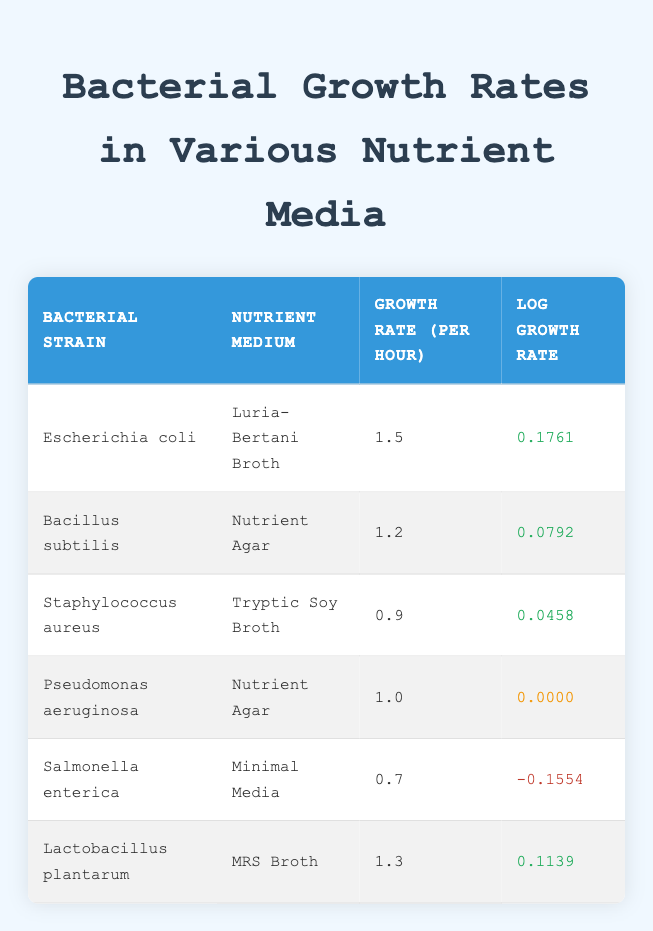What is the growth rate per hour of Escherichia coli in Luria-Bertani Broth? The table directly shows that the growth rate per hour for Escherichia coli in Luria-Bertani Broth is 1.5.
Answer: 1.5 Which bacterial strain has the highest growth rate per hour? By comparing the growth rates of all strains, Escherichia coli has the highest growth rate of 1.5 per hour.
Answer: Escherichia coli What is the log growth rate of Salmonella enterica? The table indicates that the log growth rate for Salmonella enterica is -0.1554.
Answer: -0.1554 Is the growth rate of Staphylococcus aureus higher than that of Pseudomonas aeruginosa? Staphylococcus aureus has a growth rate of 0.9, while Pseudomonas aeruginosa has a growth rate of 1.0, so Staphylococcus aureus's growth rate is not higher.
Answer: No What is the average growth rate per hour of Lactobacillus plantarum and Bacillus subtilis? The growth rates are 1.3 for Lactobacillus plantarum and 1.2 for Bacillus subtilis. Adding these gives 1.3 + 1.2 = 2.5, and dividing by 2 gives an average of 2.5 / 2 = 1.25.
Answer: 1.25 Which nutrient medium supports the fastest growth rate? Comparing all growth rates, Luria-Bertani Broth supports the fastest growth rate at 1.5 for Escherichia coli.
Answer: Luria-Bertani Broth Do any bacterial strains have a log growth rate of zero? Yes, Pseudomonas aeruginosa has a log growth rate of 0.0000, which is zero.
Answer: Yes What is the difference in growth rates between Bacillus subtilis and Staphylococcus aureus? Bacillus subtilis has a growth rate of 1.2 and Staphylococcus aureus has 0.9. The difference is 1.2 - 0.9 = 0.3.
Answer: 0.3 Which two bacterial strains have the lowest log growth rates? Checking the table reveals that Salmonella enterica has -0.1554 and Staphylococcus aureus has 0.0458. The two with the lowest log growth rates are Salmonella enterica and Pseudomonas aeruginosa (which has a log growth rate of 0.0000).
Answer: Salmonella enterica and Pseudomonas aeruginosa 